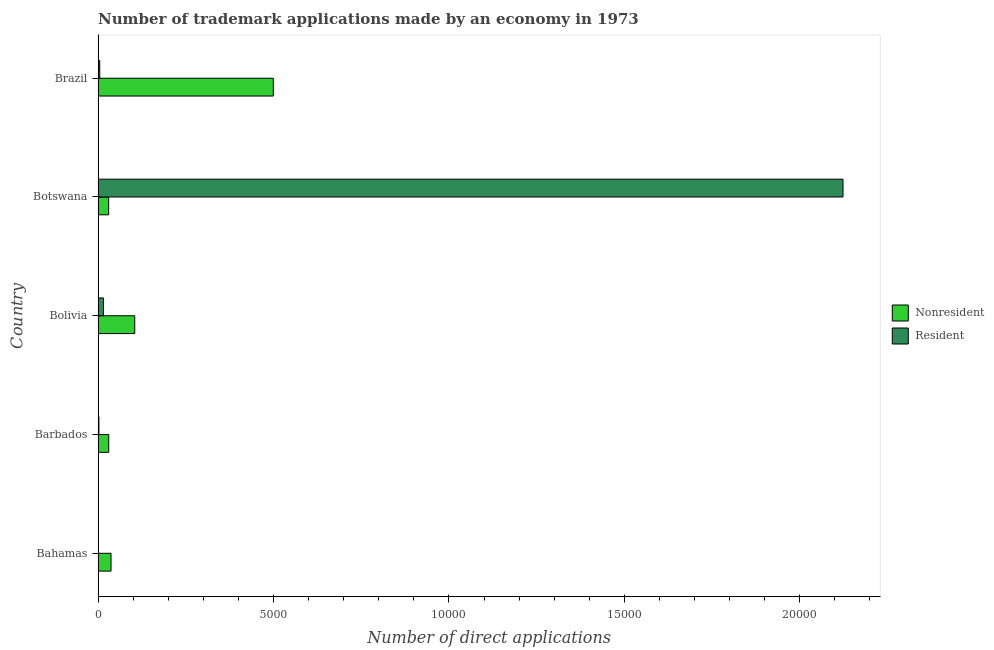How many groups of bars are there?
Provide a succinct answer. 5. How many bars are there on the 5th tick from the top?
Your response must be concise. 2. How many bars are there on the 3rd tick from the bottom?
Offer a very short reply. 2. What is the label of the 2nd group of bars from the top?
Offer a very short reply. Botswana. In how many cases, is the number of bars for a given country not equal to the number of legend labels?
Ensure brevity in your answer.  0. What is the number of trademark applications made by non residents in Botswana?
Your response must be concise. 301. Across all countries, what is the maximum number of trademark applications made by residents?
Your response must be concise. 2.12e+04. Across all countries, what is the minimum number of trademark applications made by non residents?
Offer a terse response. 301. In which country was the number of trademark applications made by non residents minimum?
Offer a terse response. Botswana. What is the total number of trademark applications made by residents in the graph?
Offer a terse response. 2.15e+04. What is the difference between the number of trademark applications made by non residents in Bahamas and that in Brazil?
Ensure brevity in your answer.  -4625. What is the difference between the number of trademark applications made by residents in Botswana and the number of trademark applications made by non residents in Bolivia?
Provide a succinct answer. 2.02e+04. What is the average number of trademark applications made by residents per country?
Make the answer very short. 4293.4. What is the difference between the number of trademark applications made by residents and number of trademark applications made by non residents in Botswana?
Provide a succinct answer. 2.09e+04. What is the ratio of the number of trademark applications made by non residents in Barbados to that in Botswana?
Provide a succinct answer. 1.01. Is the number of trademark applications made by residents in Bolivia less than that in Botswana?
Your answer should be compact. Yes. What is the difference between the highest and the second highest number of trademark applications made by non residents?
Provide a succinct answer. 3949. What is the difference between the highest and the lowest number of trademark applications made by residents?
Your response must be concise. 2.12e+04. In how many countries, is the number of trademark applications made by residents greater than the average number of trademark applications made by residents taken over all countries?
Your answer should be compact. 1. Is the sum of the number of trademark applications made by non residents in Bahamas and Brazil greater than the maximum number of trademark applications made by residents across all countries?
Keep it short and to the point. No. What does the 2nd bar from the top in Brazil represents?
Your response must be concise. Nonresident. What does the 2nd bar from the bottom in Botswana represents?
Ensure brevity in your answer.  Resident. How many bars are there?
Provide a succinct answer. 10. How many countries are there in the graph?
Offer a terse response. 5. Does the graph contain any zero values?
Offer a very short reply. No. Does the graph contain grids?
Offer a very short reply. No. How many legend labels are there?
Give a very brief answer. 2. What is the title of the graph?
Your response must be concise. Number of trademark applications made by an economy in 1973. Does "ODA received" appear as one of the legend labels in the graph?
Provide a succinct answer. No. What is the label or title of the X-axis?
Offer a very short reply. Number of direct applications. What is the Number of direct applications in Nonresident in Bahamas?
Offer a terse response. 369. What is the Number of direct applications of Resident in Bahamas?
Make the answer very short. 11. What is the Number of direct applications in Nonresident in Barbados?
Offer a terse response. 304. What is the Number of direct applications of Nonresident in Bolivia?
Make the answer very short. 1045. What is the Number of direct applications in Resident in Bolivia?
Provide a short and direct response. 152. What is the Number of direct applications in Nonresident in Botswana?
Keep it short and to the point. 301. What is the Number of direct applications in Resident in Botswana?
Make the answer very short. 2.12e+04. What is the Number of direct applications in Nonresident in Brazil?
Offer a very short reply. 4994. What is the Number of direct applications in Resident in Brazil?
Keep it short and to the point. 47. Across all countries, what is the maximum Number of direct applications of Nonresident?
Ensure brevity in your answer.  4994. Across all countries, what is the maximum Number of direct applications of Resident?
Offer a terse response. 2.12e+04. Across all countries, what is the minimum Number of direct applications of Nonresident?
Your answer should be compact. 301. Across all countries, what is the minimum Number of direct applications in Resident?
Keep it short and to the point. 11. What is the total Number of direct applications in Nonresident in the graph?
Offer a terse response. 7013. What is the total Number of direct applications of Resident in the graph?
Offer a terse response. 2.15e+04. What is the difference between the Number of direct applications in Nonresident in Bahamas and that in Barbados?
Offer a terse response. 65. What is the difference between the Number of direct applications in Nonresident in Bahamas and that in Bolivia?
Ensure brevity in your answer.  -676. What is the difference between the Number of direct applications of Resident in Bahamas and that in Bolivia?
Give a very brief answer. -141. What is the difference between the Number of direct applications of Nonresident in Bahamas and that in Botswana?
Offer a very short reply. 68. What is the difference between the Number of direct applications in Resident in Bahamas and that in Botswana?
Offer a very short reply. -2.12e+04. What is the difference between the Number of direct applications in Nonresident in Bahamas and that in Brazil?
Provide a succinct answer. -4625. What is the difference between the Number of direct applications of Resident in Bahamas and that in Brazil?
Offer a terse response. -36. What is the difference between the Number of direct applications of Nonresident in Barbados and that in Bolivia?
Keep it short and to the point. -741. What is the difference between the Number of direct applications of Resident in Barbados and that in Bolivia?
Your response must be concise. -128. What is the difference between the Number of direct applications in Nonresident in Barbados and that in Botswana?
Your answer should be compact. 3. What is the difference between the Number of direct applications in Resident in Barbados and that in Botswana?
Ensure brevity in your answer.  -2.12e+04. What is the difference between the Number of direct applications of Nonresident in Barbados and that in Brazil?
Give a very brief answer. -4690. What is the difference between the Number of direct applications of Nonresident in Bolivia and that in Botswana?
Provide a succinct answer. 744. What is the difference between the Number of direct applications of Resident in Bolivia and that in Botswana?
Make the answer very short. -2.11e+04. What is the difference between the Number of direct applications of Nonresident in Bolivia and that in Brazil?
Your answer should be compact. -3949. What is the difference between the Number of direct applications in Resident in Bolivia and that in Brazil?
Provide a short and direct response. 105. What is the difference between the Number of direct applications of Nonresident in Botswana and that in Brazil?
Offer a terse response. -4693. What is the difference between the Number of direct applications of Resident in Botswana and that in Brazil?
Give a very brief answer. 2.12e+04. What is the difference between the Number of direct applications in Nonresident in Bahamas and the Number of direct applications in Resident in Barbados?
Ensure brevity in your answer.  345. What is the difference between the Number of direct applications in Nonresident in Bahamas and the Number of direct applications in Resident in Bolivia?
Give a very brief answer. 217. What is the difference between the Number of direct applications in Nonresident in Bahamas and the Number of direct applications in Resident in Botswana?
Offer a very short reply. -2.09e+04. What is the difference between the Number of direct applications of Nonresident in Bahamas and the Number of direct applications of Resident in Brazil?
Provide a succinct answer. 322. What is the difference between the Number of direct applications in Nonresident in Barbados and the Number of direct applications in Resident in Bolivia?
Provide a short and direct response. 152. What is the difference between the Number of direct applications of Nonresident in Barbados and the Number of direct applications of Resident in Botswana?
Provide a short and direct response. -2.09e+04. What is the difference between the Number of direct applications of Nonresident in Barbados and the Number of direct applications of Resident in Brazil?
Keep it short and to the point. 257. What is the difference between the Number of direct applications in Nonresident in Bolivia and the Number of direct applications in Resident in Botswana?
Ensure brevity in your answer.  -2.02e+04. What is the difference between the Number of direct applications of Nonresident in Bolivia and the Number of direct applications of Resident in Brazil?
Your answer should be very brief. 998. What is the difference between the Number of direct applications of Nonresident in Botswana and the Number of direct applications of Resident in Brazil?
Make the answer very short. 254. What is the average Number of direct applications in Nonresident per country?
Offer a terse response. 1402.6. What is the average Number of direct applications in Resident per country?
Provide a short and direct response. 4293.4. What is the difference between the Number of direct applications of Nonresident and Number of direct applications of Resident in Bahamas?
Offer a terse response. 358. What is the difference between the Number of direct applications in Nonresident and Number of direct applications in Resident in Barbados?
Give a very brief answer. 280. What is the difference between the Number of direct applications of Nonresident and Number of direct applications of Resident in Bolivia?
Your answer should be compact. 893. What is the difference between the Number of direct applications of Nonresident and Number of direct applications of Resident in Botswana?
Provide a succinct answer. -2.09e+04. What is the difference between the Number of direct applications in Nonresident and Number of direct applications in Resident in Brazil?
Provide a short and direct response. 4947. What is the ratio of the Number of direct applications of Nonresident in Bahamas to that in Barbados?
Your response must be concise. 1.21. What is the ratio of the Number of direct applications of Resident in Bahamas to that in Barbados?
Offer a terse response. 0.46. What is the ratio of the Number of direct applications of Nonresident in Bahamas to that in Bolivia?
Your response must be concise. 0.35. What is the ratio of the Number of direct applications in Resident in Bahamas to that in Bolivia?
Your answer should be very brief. 0.07. What is the ratio of the Number of direct applications of Nonresident in Bahamas to that in Botswana?
Keep it short and to the point. 1.23. What is the ratio of the Number of direct applications in Resident in Bahamas to that in Botswana?
Provide a succinct answer. 0. What is the ratio of the Number of direct applications of Nonresident in Bahamas to that in Brazil?
Keep it short and to the point. 0.07. What is the ratio of the Number of direct applications in Resident in Bahamas to that in Brazil?
Your response must be concise. 0.23. What is the ratio of the Number of direct applications of Nonresident in Barbados to that in Bolivia?
Keep it short and to the point. 0.29. What is the ratio of the Number of direct applications of Resident in Barbados to that in Bolivia?
Provide a succinct answer. 0.16. What is the ratio of the Number of direct applications in Nonresident in Barbados to that in Botswana?
Keep it short and to the point. 1.01. What is the ratio of the Number of direct applications in Resident in Barbados to that in Botswana?
Give a very brief answer. 0. What is the ratio of the Number of direct applications of Nonresident in Barbados to that in Brazil?
Your answer should be compact. 0.06. What is the ratio of the Number of direct applications of Resident in Barbados to that in Brazil?
Offer a terse response. 0.51. What is the ratio of the Number of direct applications of Nonresident in Bolivia to that in Botswana?
Provide a short and direct response. 3.47. What is the ratio of the Number of direct applications of Resident in Bolivia to that in Botswana?
Offer a terse response. 0.01. What is the ratio of the Number of direct applications in Nonresident in Bolivia to that in Brazil?
Offer a very short reply. 0.21. What is the ratio of the Number of direct applications of Resident in Bolivia to that in Brazil?
Give a very brief answer. 3.23. What is the ratio of the Number of direct applications in Nonresident in Botswana to that in Brazil?
Your answer should be very brief. 0.06. What is the ratio of the Number of direct applications in Resident in Botswana to that in Brazil?
Make the answer very short. 451.77. What is the difference between the highest and the second highest Number of direct applications of Nonresident?
Provide a succinct answer. 3949. What is the difference between the highest and the second highest Number of direct applications in Resident?
Provide a succinct answer. 2.11e+04. What is the difference between the highest and the lowest Number of direct applications of Nonresident?
Give a very brief answer. 4693. What is the difference between the highest and the lowest Number of direct applications in Resident?
Your answer should be compact. 2.12e+04. 